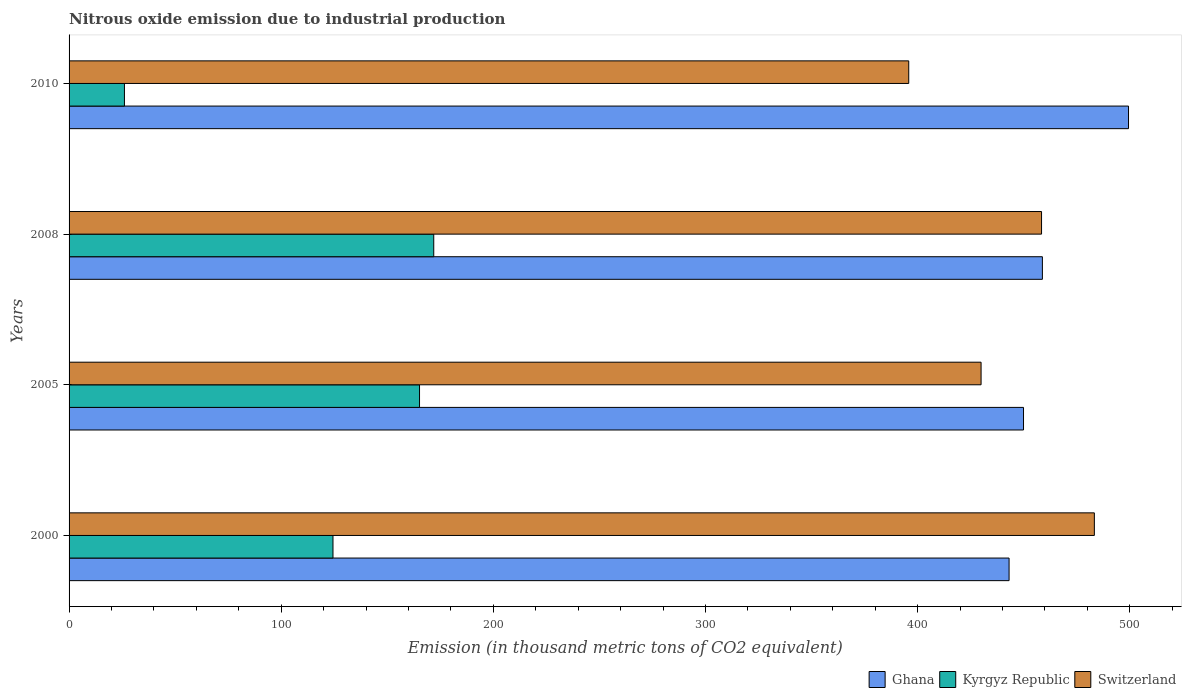How many different coloured bars are there?
Offer a terse response. 3. How many groups of bars are there?
Make the answer very short. 4. Are the number of bars per tick equal to the number of legend labels?
Offer a very short reply. Yes. Are the number of bars on each tick of the Y-axis equal?
Provide a short and direct response. Yes. How many bars are there on the 1st tick from the top?
Your answer should be very brief. 3. How many bars are there on the 4th tick from the bottom?
Give a very brief answer. 3. In how many cases, is the number of bars for a given year not equal to the number of legend labels?
Your response must be concise. 0. What is the amount of nitrous oxide emitted in Ghana in 2010?
Make the answer very short. 499.4. Across all years, what is the maximum amount of nitrous oxide emitted in Switzerland?
Provide a short and direct response. 483.3. Across all years, what is the minimum amount of nitrous oxide emitted in Switzerland?
Provide a succinct answer. 395.8. In which year was the amount of nitrous oxide emitted in Ghana maximum?
Provide a succinct answer. 2010. In which year was the amount of nitrous oxide emitted in Ghana minimum?
Your answer should be very brief. 2000. What is the total amount of nitrous oxide emitted in Kyrgyz Republic in the graph?
Your answer should be very brief. 487.6. What is the difference between the amount of nitrous oxide emitted in Kyrgyz Republic in 2005 and that in 2010?
Provide a succinct answer. 139.1. What is the difference between the amount of nitrous oxide emitted in Kyrgyz Republic in 2005 and the amount of nitrous oxide emitted in Switzerland in 2000?
Your response must be concise. -318.1. What is the average amount of nitrous oxide emitted in Switzerland per year?
Ensure brevity in your answer.  441.85. In the year 2008, what is the difference between the amount of nitrous oxide emitted in Switzerland and amount of nitrous oxide emitted in Kyrgyz Republic?
Ensure brevity in your answer.  286.5. What is the ratio of the amount of nitrous oxide emitted in Kyrgyz Republic in 2000 to that in 2008?
Offer a terse response. 0.72. Is the amount of nitrous oxide emitted in Ghana in 2008 less than that in 2010?
Your answer should be very brief. Yes. What is the difference between the highest and the second highest amount of nitrous oxide emitted in Switzerland?
Your response must be concise. 24.9. What is the difference between the highest and the lowest amount of nitrous oxide emitted in Kyrgyz Republic?
Your answer should be very brief. 145.8. In how many years, is the amount of nitrous oxide emitted in Switzerland greater than the average amount of nitrous oxide emitted in Switzerland taken over all years?
Offer a terse response. 2. Is the sum of the amount of nitrous oxide emitted in Kyrgyz Republic in 2005 and 2010 greater than the maximum amount of nitrous oxide emitted in Switzerland across all years?
Provide a short and direct response. No. What does the 1st bar from the top in 2005 represents?
Ensure brevity in your answer.  Switzerland. How many bars are there?
Provide a succinct answer. 12. How many years are there in the graph?
Offer a terse response. 4. What is the difference between two consecutive major ticks on the X-axis?
Provide a succinct answer. 100. Are the values on the major ticks of X-axis written in scientific E-notation?
Your response must be concise. No. Does the graph contain grids?
Give a very brief answer. No. How are the legend labels stacked?
Give a very brief answer. Horizontal. What is the title of the graph?
Your answer should be very brief. Nitrous oxide emission due to industrial production. What is the label or title of the X-axis?
Ensure brevity in your answer.  Emission (in thousand metric tons of CO2 equivalent). What is the label or title of the Y-axis?
Your answer should be very brief. Years. What is the Emission (in thousand metric tons of CO2 equivalent) in Ghana in 2000?
Keep it short and to the point. 443.1. What is the Emission (in thousand metric tons of CO2 equivalent) in Kyrgyz Republic in 2000?
Offer a very short reply. 124.4. What is the Emission (in thousand metric tons of CO2 equivalent) of Switzerland in 2000?
Your answer should be compact. 483.3. What is the Emission (in thousand metric tons of CO2 equivalent) in Ghana in 2005?
Your answer should be very brief. 449.9. What is the Emission (in thousand metric tons of CO2 equivalent) of Kyrgyz Republic in 2005?
Your response must be concise. 165.2. What is the Emission (in thousand metric tons of CO2 equivalent) in Switzerland in 2005?
Give a very brief answer. 429.9. What is the Emission (in thousand metric tons of CO2 equivalent) in Ghana in 2008?
Give a very brief answer. 458.8. What is the Emission (in thousand metric tons of CO2 equivalent) of Kyrgyz Republic in 2008?
Your answer should be compact. 171.9. What is the Emission (in thousand metric tons of CO2 equivalent) of Switzerland in 2008?
Your answer should be very brief. 458.4. What is the Emission (in thousand metric tons of CO2 equivalent) of Ghana in 2010?
Your answer should be very brief. 499.4. What is the Emission (in thousand metric tons of CO2 equivalent) of Kyrgyz Republic in 2010?
Offer a terse response. 26.1. What is the Emission (in thousand metric tons of CO2 equivalent) of Switzerland in 2010?
Offer a very short reply. 395.8. Across all years, what is the maximum Emission (in thousand metric tons of CO2 equivalent) in Ghana?
Offer a very short reply. 499.4. Across all years, what is the maximum Emission (in thousand metric tons of CO2 equivalent) in Kyrgyz Republic?
Ensure brevity in your answer.  171.9. Across all years, what is the maximum Emission (in thousand metric tons of CO2 equivalent) in Switzerland?
Your answer should be very brief. 483.3. Across all years, what is the minimum Emission (in thousand metric tons of CO2 equivalent) in Ghana?
Provide a succinct answer. 443.1. Across all years, what is the minimum Emission (in thousand metric tons of CO2 equivalent) of Kyrgyz Republic?
Offer a terse response. 26.1. Across all years, what is the minimum Emission (in thousand metric tons of CO2 equivalent) in Switzerland?
Make the answer very short. 395.8. What is the total Emission (in thousand metric tons of CO2 equivalent) in Ghana in the graph?
Give a very brief answer. 1851.2. What is the total Emission (in thousand metric tons of CO2 equivalent) of Kyrgyz Republic in the graph?
Offer a terse response. 487.6. What is the total Emission (in thousand metric tons of CO2 equivalent) of Switzerland in the graph?
Your response must be concise. 1767.4. What is the difference between the Emission (in thousand metric tons of CO2 equivalent) in Kyrgyz Republic in 2000 and that in 2005?
Provide a succinct answer. -40.8. What is the difference between the Emission (in thousand metric tons of CO2 equivalent) in Switzerland in 2000 and that in 2005?
Provide a succinct answer. 53.4. What is the difference between the Emission (in thousand metric tons of CO2 equivalent) in Ghana in 2000 and that in 2008?
Your answer should be very brief. -15.7. What is the difference between the Emission (in thousand metric tons of CO2 equivalent) of Kyrgyz Republic in 2000 and that in 2008?
Your response must be concise. -47.5. What is the difference between the Emission (in thousand metric tons of CO2 equivalent) in Switzerland in 2000 and that in 2008?
Your answer should be very brief. 24.9. What is the difference between the Emission (in thousand metric tons of CO2 equivalent) in Ghana in 2000 and that in 2010?
Your answer should be very brief. -56.3. What is the difference between the Emission (in thousand metric tons of CO2 equivalent) of Kyrgyz Republic in 2000 and that in 2010?
Your answer should be very brief. 98.3. What is the difference between the Emission (in thousand metric tons of CO2 equivalent) in Switzerland in 2000 and that in 2010?
Provide a short and direct response. 87.5. What is the difference between the Emission (in thousand metric tons of CO2 equivalent) in Ghana in 2005 and that in 2008?
Offer a very short reply. -8.9. What is the difference between the Emission (in thousand metric tons of CO2 equivalent) of Switzerland in 2005 and that in 2008?
Ensure brevity in your answer.  -28.5. What is the difference between the Emission (in thousand metric tons of CO2 equivalent) in Ghana in 2005 and that in 2010?
Ensure brevity in your answer.  -49.5. What is the difference between the Emission (in thousand metric tons of CO2 equivalent) in Kyrgyz Republic in 2005 and that in 2010?
Your response must be concise. 139.1. What is the difference between the Emission (in thousand metric tons of CO2 equivalent) of Switzerland in 2005 and that in 2010?
Provide a short and direct response. 34.1. What is the difference between the Emission (in thousand metric tons of CO2 equivalent) of Ghana in 2008 and that in 2010?
Provide a short and direct response. -40.6. What is the difference between the Emission (in thousand metric tons of CO2 equivalent) in Kyrgyz Republic in 2008 and that in 2010?
Your answer should be very brief. 145.8. What is the difference between the Emission (in thousand metric tons of CO2 equivalent) of Switzerland in 2008 and that in 2010?
Make the answer very short. 62.6. What is the difference between the Emission (in thousand metric tons of CO2 equivalent) of Ghana in 2000 and the Emission (in thousand metric tons of CO2 equivalent) of Kyrgyz Republic in 2005?
Keep it short and to the point. 277.9. What is the difference between the Emission (in thousand metric tons of CO2 equivalent) of Ghana in 2000 and the Emission (in thousand metric tons of CO2 equivalent) of Switzerland in 2005?
Your answer should be very brief. 13.2. What is the difference between the Emission (in thousand metric tons of CO2 equivalent) in Kyrgyz Republic in 2000 and the Emission (in thousand metric tons of CO2 equivalent) in Switzerland in 2005?
Offer a very short reply. -305.5. What is the difference between the Emission (in thousand metric tons of CO2 equivalent) of Ghana in 2000 and the Emission (in thousand metric tons of CO2 equivalent) of Kyrgyz Republic in 2008?
Provide a short and direct response. 271.2. What is the difference between the Emission (in thousand metric tons of CO2 equivalent) of Ghana in 2000 and the Emission (in thousand metric tons of CO2 equivalent) of Switzerland in 2008?
Ensure brevity in your answer.  -15.3. What is the difference between the Emission (in thousand metric tons of CO2 equivalent) of Kyrgyz Republic in 2000 and the Emission (in thousand metric tons of CO2 equivalent) of Switzerland in 2008?
Offer a terse response. -334. What is the difference between the Emission (in thousand metric tons of CO2 equivalent) in Ghana in 2000 and the Emission (in thousand metric tons of CO2 equivalent) in Kyrgyz Republic in 2010?
Keep it short and to the point. 417. What is the difference between the Emission (in thousand metric tons of CO2 equivalent) in Ghana in 2000 and the Emission (in thousand metric tons of CO2 equivalent) in Switzerland in 2010?
Keep it short and to the point. 47.3. What is the difference between the Emission (in thousand metric tons of CO2 equivalent) in Kyrgyz Republic in 2000 and the Emission (in thousand metric tons of CO2 equivalent) in Switzerland in 2010?
Your response must be concise. -271.4. What is the difference between the Emission (in thousand metric tons of CO2 equivalent) in Ghana in 2005 and the Emission (in thousand metric tons of CO2 equivalent) in Kyrgyz Republic in 2008?
Make the answer very short. 278. What is the difference between the Emission (in thousand metric tons of CO2 equivalent) in Ghana in 2005 and the Emission (in thousand metric tons of CO2 equivalent) in Switzerland in 2008?
Offer a terse response. -8.5. What is the difference between the Emission (in thousand metric tons of CO2 equivalent) of Kyrgyz Republic in 2005 and the Emission (in thousand metric tons of CO2 equivalent) of Switzerland in 2008?
Provide a short and direct response. -293.2. What is the difference between the Emission (in thousand metric tons of CO2 equivalent) of Ghana in 2005 and the Emission (in thousand metric tons of CO2 equivalent) of Kyrgyz Republic in 2010?
Ensure brevity in your answer.  423.8. What is the difference between the Emission (in thousand metric tons of CO2 equivalent) in Ghana in 2005 and the Emission (in thousand metric tons of CO2 equivalent) in Switzerland in 2010?
Your answer should be compact. 54.1. What is the difference between the Emission (in thousand metric tons of CO2 equivalent) of Kyrgyz Republic in 2005 and the Emission (in thousand metric tons of CO2 equivalent) of Switzerland in 2010?
Give a very brief answer. -230.6. What is the difference between the Emission (in thousand metric tons of CO2 equivalent) in Ghana in 2008 and the Emission (in thousand metric tons of CO2 equivalent) in Kyrgyz Republic in 2010?
Offer a very short reply. 432.7. What is the difference between the Emission (in thousand metric tons of CO2 equivalent) in Kyrgyz Republic in 2008 and the Emission (in thousand metric tons of CO2 equivalent) in Switzerland in 2010?
Your response must be concise. -223.9. What is the average Emission (in thousand metric tons of CO2 equivalent) in Ghana per year?
Your answer should be very brief. 462.8. What is the average Emission (in thousand metric tons of CO2 equivalent) of Kyrgyz Republic per year?
Offer a very short reply. 121.9. What is the average Emission (in thousand metric tons of CO2 equivalent) of Switzerland per year?
Provide a succinct answer. 441.85. In the year 2000, what is the difference between the Emission (in thousand metric tons of CO2 equivalent) of Ghana and Emission (in thousand metric tons of CO2 equivalent) of Kyrgyz Republic?
Give a very brief answer. 318.7. In the year 2000, what is the difference between the Emission (in thousand metric tons of CO2 equivalent) of Ghana and Emission (in thousand metric tons of CO2 equivalent) of Switzerland?
Offer a very short reply. -40.2. In the year 2000, what is the difference between the Emission (in thousand metric tons of CO2 equivalent) in Kyrgyz Republic and Emission (in thousand metric tons of CO2 equivalent) in Switzerland?
Your answer should be compact. -358.9. In the year 2005, what is the difference between the Emission (in thousand metric tons of CO2 equivalent) in Ghana and Emission (in thousand metric tons of CO2 equivalent) in Kyrgyz Republic?
Keep it short and to the point. 284.7. In the year 2005, what is the difference between the Emission (in thousand metric tons of CO2 equivalent) of Kyrgyz Republic and Emission (in thousand metric tons of CO2 equivalent) of Switzerland?
Provide a succinct answer. -264.7. In the year 2008, what is the difference between the Emission (in thousand metric tons of CO2 equivalent) in Ghana and Emission (in thousand metric tons of CO2 equivalent) in Kyrgyz Republic?
Offer a very short reply. 286.9. In the year 2008, what is the difference between the Emission (in thousand metric tons of CO2 equivalent) in Ghana and Emission (in thousand metric tons of CO2 equivalent) in Switzerland?
Offer a very short reply. 0.4. In the year 2008, what is the difference between the Emission (in thousand metric tons of CO2 equivalent) of Kyrgyz Republic and Emission (in thousand metric tons of CO2 equivalent) of Switzerland?
Offer a very short reply. -286.5. In the year 2010, what is the difference between the Emission (in thousand metric tons of CO2 equivalent) of Ghana and Emission (in thousand metric tons of CO2 equivalent) of Kyrgyz Republic?
Give a very brief answer. 473.3. In the year 2010, what is the difference between the Emission (in thousand metric tons of CO2 equivalent) in Ghana and Emission (in thousand metric tons of CO2 equivalent) in Switzerland?
Your response must be concise. 103.6. In the year 2010, what is the difference between the Emission (in thousand metric tons of CO2 equivalent) of Kyrgyz Republic and Emission (in thousand metric tons of CO2 equivalent) of Switzerland?
Ensure brevity in your answer.  -369.7. What is the ratio of the Emission (in thousand metric tons of CO2 equivalent) of Ghana in 2000 to that in 2005?
Make the answer very short. 0.98. What is the ratio of the Emission (in thousand metric tons of CO2 equivalent) in Kyrgyz Republic in 2000 to that in 2005?
Offer a very short reply. 0.75. What is the ratio of the Emission (in thousand metric tons of CO2 equivalent) of Switzerland in 2000 to that in 2005?
Your answer should be very brief. 1.12. What is the ratio of the Emission (in thousand metric tons of CO2 equivalent) in Ghana in 2000 to that in 2008?
Offer a terse response. 0.97. What is the ratio of the Emission (in thousand metric tons of CO2 equivalent) in Kyrgyz Republic in 2000 to that in 2008?
Your answer should be very brief. 0.72. What is the ratio of the Emission (in thousand metric tons of CO2 equivalent) of Switzerland in 2000 to that in 2008?
Your response must be concise. 1.05. What is the ratio of the Emission (in thousand metric tons of CO2 equivalent) in Ghana in 2000 to that in 2010?
Your answer should be very brief. 0.89. What is the ratio of the Emission (in thousand metric tons of CO2 equivalent) in Kyrgyz Republic in 2000 to that in 2010?
Offer a terse response. 4.77. What is the ratio of the Emission (in thousand metric tons of CO2 equivalent) in Switzerland in 2000 to that in 2010?
Give a very brief answer. 1.22. What is the ratio of the Emission (in thousand metric tons of CO2 equivalent) of Ghana in 2005 to that in 2008?
Provide a short and direct response. 0.98. What is the ratio of the Emission (in thousand metric tons of CO2 equivalent) in Kyrgyz Republic in 2005 to that in 2008?
Offer a terse response. 0.96. What is the ratio of the Emission (in thousand metric tons of CO2 equivalent) of Switzerland in 2005 to that in 2008?
Your answer should be very brief. 0.94. What is the ratio of the Emission (in thousand metric tons of CO2 equivalent) of Ghana in 2005 to that in 2010?
Offer a very short reply. 0.9. What is the ratio of the Emission (in thousand metric tons of CO2 equivalent) of Kyrgyz Republic in 2005 to that in 2010?
Keep it short and to the point. 6.33. What is the ratio of the Emission (in thousand metric tons of CO2 equivalent) of Switzerland in 2005 to that in 2010?
Make the answer very short. 1.09. What is the ratio of the Emission (in thousand metric tons of CO2 equivalent) in Ghana in 2008 to that in 2010?
Provide a short and direct response. 0.92. What is the ratio of the Emission (in thousand metric tons of CO2 equivalent) of Kyrgyz Republic in 2008 to that in 2010?
Make the answer very short. 6.59. What is the ratio of the Emission (in thousand metric tons of CO2 equivalent) of Switzerland in 2008 to that in 2010?
Provide a short and direct response. 1.16. What is the difference between the highest and the second highest Emission (in thousand metric tons of CO2 equivalent) of Ghana?
Your response must be concise. 40.6. What is the difference between the highest and the second highest Emission (in thousand metric tons of CO2 equivalent) of Switzerland?
Make the answer very short. 24.9. What is the difference between the highest and the lowest Emission (in thousand metric tons of CO2 equivalent) of Ghana?
Keep it short and to the point. 56.3. What is the difference between the highest and the lowest Emission (in thousand metric tons of CO2 equivalent) of Kyrgyz Republic?
Provide a short and direct response. 145.8. What is the difference between the highest and the lowest Emission (in thousand metric tons of CO2 equivalent) of Switzerland?
Ensure brevity in your answer.  87.5. 